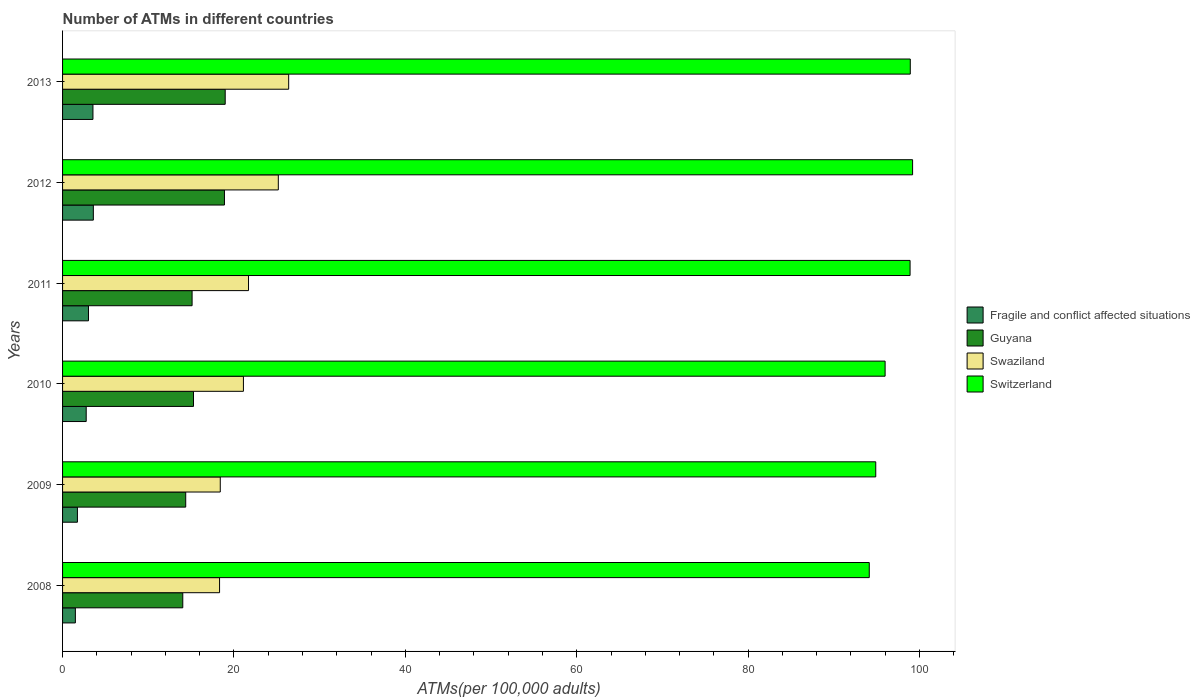How many different coloured bars are there?
Your response must be concise. 4. How many groups of bars are there?
Keep it short and to the point. 6. Are the number of bars per tick equal to the number of legend labels?
Ensure brevity in your answer.  Yes. How many bars are there on the 3rd tick from the top?
Provide a succinct answer. 4. In how many cases, is the number of bars for a given year not equal to the number of legend labels?
Offer a terse response. 0. What is the number of ATMs in Switzerland in 2009?
Offer a very short reply. 94.89. Across all years, what is the maximum number of ATMs in Guyana?
Ensure brevity in your answer.  18.98. Across all years, what is the minimum number of ATMs in Fragile and conflict affected situations?
Keep it short and to the point. 1.49. What is the total number of ATMs in Fragile and conflict affected situations in the graph?
Your answer should be very brief. 16.15. What is the difference between the number of ATMs in Guyana in 2011 and that in 2013?
Give a very brief answer. -3.86. What is the difference between the number of ATMs in Guyana in 2011 and the number of ATMs in Switzerland in 2013?
Provide a succinct answer. -83.81. What is the average number of ATMs in Swaziland per year?
Provide a succinct answer. 21.85. In the year 2008, what is the difference between the number of ATMs in Switzerland and number of ATMs in Fragile and conflict affected situations?
Give a very brief answer. 92.64. What is the ratio of the number of ATMs in Swaziland in 2008 to that in 2011?
Give a very brief answer. 0.84. Is the difference between the number of ATMs in Switzerland in 2008 and 2010 greater than the difference between the number of ATMs in Fragile and conflict affected situations in 2008 and 2010?
Give a very brief answer. No. What is the difference between the highest and the second highest number of ATMs in Guyana?
Give a very brief answer. 0.09. What is the difference between the highest and the lowest number of ATMs in Guyana?
Your answer should be very brief. 4.95. In how many years, is the number of ATMs in Swaziland greater than the average number of ATMs in Swaziland taken over all years?
Provide a succinct answer. 2. Is the sum of the number of ATMs in Swaziland in 2008 and 2012 greater than the maximum number of ATMs in Fragile and conflict affected situations across all years?
Make the answer very short. Yes. Is it the case that in every year, the sum of the number of ATMs in Guyana and number of ATMs in Switzerland is greater than the sum of number of ATMs in Fragile and conflict affected situations and number of ATMs in Swaziland?
Your response must be concise. Yes. What does the 2nd bar from the top in 2010 represents?
Make the answer very short. Swaziland. What does the 1st bar from the bottom in 2009 represents?
Keep it short and to the point. Fragile and conflict affected situations. Is it the case that in every year, the sum of the number of ATMs in Switzerland and number of ATMs in Guyana is greater than the number of ATMs in Swaziland?
Keep it short and to the point. Yes. How many bars are there?
Provide a short and direct response. 24. Are all the bars in the graph horizontal?
Keep it short and to the point. Yes. Are the values on the major ticks of X-axis written in scientific E-notation?
Make the answer very short. No. Does the graph contain any zero values?
Make the answer very short. No. Does the graph contain grids?
Make the answer very short. No. How many legend labels are there?
Your answer should be very brief. 4. How are the legend labels stacked?
Provide a succinct answer. Vertical. What is the title of the graph?
Give a very brief answer. Number of ATMs in different countries. What is the label or title of the X-axis?
Provide a short and direct response. ATMs(per 100,0 adults). What is the label or title of the Y-axis?
Offer a terse response. Years. What is the ATMs(per 100,000 adults) in Fragile and conflict affected situations in 2008?
Provide a succinct answer. 1.49. What is the ATMs(per 100,000 adults) of Guyana in 2008?
Your answer should be compact. 14.03. What is the ATMs(per 100,000 adults) of Swaziland in 2008?
Provide a succinct answer. 18.32. What is the ATMs(per 100,000 adults) of Switzerland in 2008?
Offer a very short reply. 94.14. What is the ATMs(per 100,000 adults) in Fragile and conflict affected situations in 2009?
Keep it short and to the point. 1.73. What is the ATMs(per 100,000 adults) of Guyana in 2009?
Offer a very short reply. 14.37. What is the ATMs(per 100,000 adults) in Swaziland in 2009?
Provide a short and direct response. 18.4. What is the ATMs(per 100,000 adults) in Switzerland in 2009?
Ensure brevity in your answer.  94.89. What is the ATMs(per 100,000 adults) in Fragile and conflict affected situations in 2010?
Provide a succinct answer. 2.76. What is the ATMs(per 100,000 adults) in Guyana in 2010?
Your answer should be very brief. 15.28. What is the ATMs(per 100,000 adults) in Swaziland in 2010?
Provide a short and direct response. 21.1. What is the ATMs(per 100,000 adults) of Switzerland in 2010?
Your answer should be compact. 95.98. What is the ATMs(per 100,000 adults) in Fragile and conflict affected situations in 2011?
Your response must be concise. 3.02. What is the ATMs(per 100,000 adults) in Guyana in 2011?
Your answer should be very brief. 15.12. What is the ATMs(per 100,000 adults) of Swaziland in 2011?
Make the answer very short. 21.7. What is the ATMs(per 100,000 adults) of Switzerland in 2011?
Make the answer very short. 98.9. What is the ATMs(per 100,000 adults) of Fragile and conflict affected situations in 2012?
Offer a very short reply. 3.59. What is the ATMs(per 100,000 adults) of Guyana in 2012?
Make the answer very short. 18.89. What is the ATMs(per 100,000 adults) of Swaziland in 2012?
Make the answer very short. 25.18. What is the ATMs(per 100,000 adults) in Switzerland in 2012?
Keep it short and to the point. 99.19. What is the ATMs(per 100,000 adults) in Fragile and conflict affected situations in 2013?
Make the answer very short. 3.55. What is the ATMs(per 100,000 adults) of Guyana in 2013?
Your response must be concise. 18.98. What is the ATMs(per 100,000 adults) of Swaziland in 2013?
Ensure brevity in your answer.  26.38. What is the ATMs(per 100,000 adults) of Switzerland in 2013?
Provide a succinct answer. 98.92. Across all years, what is the maximum ATMs(per 100,000 adults) in Fragile and conflict affected situations?
Make the answer very short. 3.59. Across all years, what is the maximum ATMs(per 100,000 adults) in Guyana?
Your answer should be compact. 18.98. Across all years, what is the maximum ATMs(per 100,000 adults) of Swaziland?
Give a very brief answer. 26.38. Across all years, what is the maximum ATMs(per 100,000 adults) in Switzerland?
Offer a very short reply. 99.19. Across all years, what is the minimum ATMs(per 100,000 adults) in Fragile and conflict affected situations?
Make the answer very short. 1.49. Across all years, what is the minimum ATMs(per 100,000 adults) in Guyana?
Make the answer very short. 14.03. Across all years, what is the minimum ATMs(per 100,000 adults) of Swaziland?
Provide a succinct answer. 18.32. Across all years, what is the minimum ATMs(per 100,000 adults) in Switzerland?
Your answer should be very brief. 94.14. What is the total ATMs(per 100,000 adults) in Fragile and conflict affected situations in the graph?
Offer a very short reply. 16.15. What is the total ATMs(per 100,000 adults) of Guyana in the graph?
Your response must be concise. 96.66. What is the total ATMs(per 100,000 adults) in Swaziland in the graph?
Your answer should be compact. 131.09. What is the total ATMs(per 100,000 adults) of Switzerland in the graph?
Ensure brevity in your answer.  582.03. What is the difference between the ATMs(per 100,000 adults) of Fragile and conflict affected situations in 2008 and that in 2009?
Ensure brevity in your answer.  -0.24. What is the difference between the ATMs(per 100,000 adults) in Guyana in 2008 and that in 2009?
Offer a very short reply. -0.34. What is the difference between the ATMs(per 100,000 adults) in Swaziland in 2008 and that in 2009?
Offer a very short reply. -0.08. What is the difference between the ATMs(per 100,000 adults) in Switzerland in 2008 and that in 2009?
Provide a short and direct response. -0.76. What is the difference between the ATMs(per 100,000 adults) of Fragile and conflict affected situations in 2008 and that in 2010?
Offer a very short reply. -1.26. What is the difference between the ATMs(per 100,000 adults) in Guyana in 2008 and that in 2010?
Give a very brief answer. -1.25. What is the difference between the ATMs(per 100,000 adults) in Swaziland in 2008 and that in 2010?
Keep it short and to the point. -2.78. What is the difference between the ATMs(per 100,000 adults) of Switzerland in 2008 and that in 2010?
Your answer should be very brief. -1.85. What is the difference between the ATMs(per 100,000 adults) of Fragile and conflict affected situations in 2008 and that in 2011?
Make the answer very short. -1.53. What is the difference between the ATMs(per 100,000 adults) in Guyana in 2008 and that in 2011?
Give a very brief answer. -1.09. What is the difference between the ATMs(per 100,000 adults) in Swaziland in 2008 and that in 2011?
Give a very brief answer. -3.38. What is the difference between the ATMs(per 100,000 adults) in Switzerland in 2008 and that in 2011?
Make the answer very short. -4.76. What is the difference between the ATMs(per 100,000 adults) of Fragile and conflict affected situations in 2008 and that in 2012?
Your answer should be very brief. -2.1. What is the difference between the ATMs(per 100,000 adults) of Guyana in 2008 and that in 2012?
Your answer should be compact. -4.86. What is the difference between the ATMs(per 100,000 adults) of Swaziland in 2008 and that in 2012?
Provide a succinct answer. -6.86. What is the difference between the ATMs(per 100,000 adults) in Switzerland in 2008 and that in 2012?
Make the answer very short. -5.06. What is the difference between the ATMs(per 100,000 adults) in Fragile and conflict affected situations in 2008 and that in 2013?
Offer a very short reply. -2.05. What is the difference between the ATMs(per 100,000 adults) of Guyana in 2008 and that in 2013?
Your answer should be very brief. -4.95. What is the difference between the ATMs(per 100,000 adults) of Swaziland in 2008 and that in 2013?
Offer a terse response. -8.06. What is the difference between the ATMs(per 100,000 adults) in Switzerland in 2008 and that in 2013?
Offer a very short reply. -4.79. What is the difference between the ATMs(per 100,000 adults) in Fragile and conflict affected situations in 2009 and that in 2010?
Your answer should be very brief. -1.03. What is the difference between the ATMs(per 100,000 adults) in Guyana in 2009 and that in 2010?
Keep it short and to the point. -0.91. What is the difference between the ATMs(per 100,000 adults) in Swaziland in 2009 and that in 2010?
Your response must be concise. -2.7. What is the difference between the ATMs(per 100,000 adults) in Switzerland in 2009 and that in 2010?
Make the answer very short. -1.09. What is the difference between the ATMs(per 100,000 adults) in Fragile and conflict affected situations in 2009 and that in 2011?
Provide a short and direct response. -1.29. What is the difference between the ATMs(per 100,000 adults) in Guyana in 2009 and that in 2011?
Offer a terse response. -0.75. What is the difference between the ATMs(per 100,000 adults) of Swaziland in 2009 and that in 2011?
Give a very brief answer. -3.3. What is the difference between the ATMs(per 100,000 adults) in Switzerland in 2009 and that in 2011?
Give a very brief answer. -4. What is the difference between the ATMs(per 100,000 adults) in Fragile and conflict affected situations in 2009 and that in 2012?
Your answer should be very brief. -1.86. What is the difference between the ATMs(per 100,000 adults) in Guyana in 2009 and that in 2012?
Give a very brief answer. -4.52. What is the difference between the ATMs(per 100,000 adults) of Swaziland in 2009 and that in 2012?
Provide a short and direct response. -6.77. What is the difference between the ATMs(per 100,000 adults) in Switzerland in 2009 and that in 2012?
Give a very brief answer. -4.3. What is the difference between the ATMs(per 100,000 adults) of Fragile and conflict affected situations in 2009 and that in 2013?
Provide a succinct answer. -1.81. What is the difference between the ATMs(per 100,000 adults) in Guyana in 2009 and that in 2013?
Your answer should be compact. -4.61. What is the difference between the ATMs(per 100,000 adults) of Swaziland in 2009 and that in 2013?
Make the answer very short. -7.98. What is the difference between the ATMs(per 100,000 adults) in Switzerland in 2009 and that in 2013?
Give a very brief answer. -4.03. What is the difference between the ATMs(per 100,000 adults) of Fragile and conflict affected situations in 2010 and that in 2011?
Offer a terse response. -0.27. What is the difference between the ATMs(per 100,000 adults) of Guyana in 2010 and that in 2011?
Your answer should be very brief. 0.16. What is the difference between the ATMs(per 100,000 adults) in Swaziland in 2010 and that in 2011?
Your answer should be compact. -0.6. What is the difference between the ATMs(per 100,000 adults) of Switzerland in 2010 and that in 2011?
Ensure brevity in your answer.  -2.91. What is the difference between the ATMs(per 100,000 adults) in Fragile and conflict affected situations in 2010 and that in 2012?
Keep it short and to the point. -0.83. What is the difference between the ATMs(per 100,000 adults) of Guyana in 2010 and that in 2012?
Offer a terse response. -3.61. What is the difference between the ATMs(per 100,000 adults) in Swaziland in 2010 and that in 2012?
Make the answer very short. -4.07. What is the difference between the ATMs(per 100,000 adults) in Switzerland in 2010 and that in 2012?
Provide a short and direct response. -3.21. What is the difference between the ATMs(per 100,000 adults) of Fragile and conflict affected situations in 2010 and that in 2013?
Make the answer very short. -0.79. What is the difference between the ATMs(per 100,000 adults) in Guyana in 2010 and that in 2013?
Keep it short and to the point. -3.7. What is the difference between the ATMs(per 100,000 adults) in Swaziland in 2010 and that in 2013?
Offer a very short reply. -5.28. What is the difference between the ATMs(per 100,000 adults) in Switzerland in 2010 and that in 2013?
Keep it short and to the point. -2.94. What is the difference between the ATMs(per 100,000 adults) in Fragile and conflict affected situations in 2011 and that in 2012?
Provide a short and direct response. -0.57. What is the difference between the ATMs(per 100,000 adults) in Guyana in 2011 and that in 2012?
Keep it short and to the point. -3.78. What is the difference between the ATMs(per 100,000 adults) of Swaziland in 2011 and that in 2012?
Give a very brief answer. -3.48. What is the difference between the ATMs(per 100,000 adults) of Switzerland in 2011 and that in 2012?
Offer a terse response. -0.29. What is the difference between the ATMs(per 100,000 adults) in Fragile and conflict affected situations in 2011 and that in 2013?
Offer a terse response. -0.52. What is the difference between the ATMs(per 100,000 adults) in Guyana in 2011 and that in 2013?
Ensure brevity in your answer.  -3.86. What is the difference between the ATMs(per 100,000 adults) in Swaziland in 2011 and that in 2013?
Your answer should be very brief. -4.68. What is the difference between the ATMs(per 100,000 adults) in Switzerland in 2011 and that in 2013?
Make the answer very short. -0.03. What is the difference between the ATMs(per 100,000 adults) of Fragile and conflict affected situations in 2012 and that in 2013?
Provide a succinct answer. 0.05. What is the difference between the ATMs(per 100,000 adults) of Guyana in 2012 and that in 2013?
Offer a very short reply. -0.09. What is the difference between the ATMs(per 100,000 adults) in Swaziland in 2012 and that in 2013?
Ensure brevity in your answer.  -1.21. What is the difference between the ATMs(per 100,000 adults) of Switzerland in 2012 and that in 2013?
Keep it short and to the point. 0.27. What is the difference between the ATMs(per 100,000 adults) of Fragile and conflict affected situations in 2008 and the ATMs(per 100,000 adults) of Guyana in 2009?
Keep it short and to the point. -12.88. What is the difference between the ATMs(per 100,000 adults) of Fragile and conflict affected situations in 2008 and the ATMs(per 100,000 adults) of Swaziland in 2009?
Make the answer very short. -16.91. What is the difference between the ATMs(per 100,000 adults) of Fragile and conflict affected situations in 2008 and the ATMs(per 100,000 adults) of Switzerland in 2009?
Your answer should be very brief. -93.4. What is the difference between the ATMs(per 100,000 adults) of Guyana in 2008 and the ATMs(per 100,000 adults) of Swaziland in 2009?
Offer a very short reply. -4.37. What is the difference between the ATMs(per 100,000 adults) of Guyana in 2008 and the ATMs(per 100,000 adults) of Switzerland in 2009?
Offer a terse response. -80.87. What is the difference between the ATMs(per 100,000 adults) of Swaziland in 2008 and the ATMs(per 100,000 adults) of Switzerland in 2009?
Keep it short and to the point. -76.57. What is the difference between the ATMs(per 100,000 adults) of Fragile and conflict affected situations in 2008 and the ATMs(per 100,000 adults) of Guyana in 2010?
Offer a terse response. -13.79. What is the difference between the ATMs(per 100,000 adults) in Fragile and conflict affected situations in 2008 and the ATMs(per 100,000 adults) in Swaziland in 2010?
Provide a short and direct response. -19.61. What is the difference between the ATMs(per 100,000 adults) of Fragile and conflict affected situations in 2008 and the ATMs(per 100,000 adults) of Switzerland in 2010?
Give a very brief answer. -94.49. What is the difference between the ATMs(per 100,000 adults) in Guyana in 2008 and the ATMs(per 100,000 adults) in Swaziland in 2010?
Offer a very short reply. -7.08. What is the difference between the ATMs(per 100,000 adults) of Guyana in 2008 and the ATMs(per 100,000 adults) of Switzerland in 2010?
Provide a succinct answer. -81.96. What is the difference between the ATMs(per 100,000 adults) of Swaziland in 2008 and the ATMs(per 100,000 adults) of Switzerland in 2010?
Your response must be concise. -77.66. What is the difference between the ATMs(per 100,000 adults) of Fragile and conflict affected situations in 2008 and the ATMs(per 100,000 adults) of Guyana in 2011?
Give a very brief answer. -13.62. What is the difference between the ATMs(per 100,000 adults) in Fragile and conflict affected situations in 2008 and the ATMs(per 100,000 adults) in Swaziland in 2011?
Your answer should be compact. -20.21. What is the difference between the ATMs(per 100,000 adults) of Fragile and conflict affected situations in 2008 and the ATMs(per 100,000 adults) of Switzerland in 2011?
Ensure brevity in your answer.  -97.4. What is the difference between the ATMs(per 100,000 adults) in Guyana in 2008 and the ATMs(per 100,000 adults) in Swaziland in 2011?
Keep it short and to the point. -7.67. What is the difference between the ATMs(per 100,000 adults) in Guyana in 2008 and the ATMs(per 100,000 adults) in Switzerland in 2011?
Your answer should be compact. -84.87. What is the difference between the ATMs(per 100,000 adults) of Swaziland in 2008 and the ATMs(per 100,000 adults) of Switzerland in 2011?
Offer a very short reply. -80.58. What is the difference between the ATMs(per 100,000 adults) of Fragile and conflict affected situations in 2008 and the ATMs(per 100,000 adults) of Guyana in 2012?
Make the answer very short. -17.4. What is the difference between the ATMs(per 100,000 adults) in Fragile and conflict affected situations in 2008 and the ATMs(per 100,000 adults) in Swaziland in 2012?
Offer a very short reply. -23.68. What is the difference between the ATMs(per 100,000 adults) in Fragile and conflict affected situations in 2008 and the ATMs(per 100,000 adults) in Switzerland in 2012?
Your response must be concise. -97.7. What is the difference between the ATMs(per 100,000 adults) of Guyana in 2008 and the ATMs(per 100,000 adults) of Swaziland in 2012?
Keep it short and to the point. -11.15. What is the difference between the ATMs(per 100,000 adults) of Guyana in 2008 and the ATMs(per 100,000 adults) of Switzerland in 2012?
Keep it short and to the point. -85.17. What is the difference between the ATMs(per 100,000 adults) in Swaziland in 2008 and the ATMs(per 100,000 adults) in Switzerland in 2012?
Offer a terse response. -80.87. What is the difference between the ATMs(per 100,000 adults) in Fragile and conflict affected situations in 2008 and the ATMs(per 100,000 adults) in Guyana in 2013?
Provide a short and direct response. -17.48. What is the difference between the ATMs(per 100,000 adults) in Fragile and conflict affected situations in 2008 and the ATMs(per 100,000 adults) in Swaziland in 2013?
Your answer should be compact. -24.89. What is the difference between the ATMs(per 100,000 adults) in Fragile and conflict affected situations in 2008 and the ATMs(per 100,000 adults) in Switzerland in 2013?
Ensure brevity in your answer.  -97.43. What is the difference between the ATMs(per 100,000 adults) of Guyana in 2008 and the ATMs(per 100,000 adults) of Swaziland in 2013?
Make the answer very short. -12.36. What is the difference between the ATMs(per 100,000 adults) of Guyana in 2008 and the ATMs(per 100,000 adults) of Switzerland in 2013?
Offer a terse response. -84.9. What is the difference between the ATMs(per 100,000 adults) of Swaziland in 2008 and the ATMs(per 100,000 adults) of Switzerland in 2013?
Provide a short and direct response. -80.6. What is the difference between the ATMs(per 100,000 adults) in Fragile and conflict affected situations in 2009 and the ATMs(per 100,000 adults) in Guyana in 2010?
Your answer should be compact. -13.55. What is the difference between the ATMs(per 100,000 adults) in Fragile and conflict affected situations in 2009 and the ATMs(per 100,000 adults) in Swaziland in 2010?
Your answer should be compact. -19.37. What is the difference between the ATMs(per 100,000 adults) in Fragile and conflict affected situations in 2009 and the ATMs(per 100,000 adults) in Switzerland in 2010?
Ensure brevity in your answer.  -94.25. What is the difference between the ATMs(per 100,000 adults) in Guyana in 2009 and the ATMs(per 100,000 adults) in Swaziland in 2010?
Offer a very short reply. -6.73. What is the difference between the ATMs(per 100,000 adults) of Guyana in 2009 and the ATMs(per 100,000 adults) of Switzerland in 2010?
Offer a terse response. -81.61. What is the difference between the ATMs(per 100,000 adults) of Swaziland in 2009 and the ATMs(per 100,000 adults) of Switzerland in 2010?
Offer a very short reply. -77.58. What is the difference between the ATMs(per 100,000 adults) in Fragile and conflict affected situations in 2009 and the ATMs(per 100,000 adults) in Guyana in 2011?
Provide a short and direct response. -13.38. What is the difference between the ATMs(per 100,000 adults) of Fragile and conflict affected situations in 2009 and the ATMs(per 100,000 adults) of Swaziland in 2011?
Provide a succinct answer. -19.97. What is the difference between the ATMs(per 100,000 adults) in Fragile and conflict affected situations in 2009 and the ATMs(per 100,000 adults) in Switzerland in 2011?
Make the answer very short. -97.17. What is the difference between the ATMs(per 100,000 adults) of Guyana in 2009 and the ATMs(per 100,000 adults) of Swaziland in 2011?
Ensure brevity in your answer.  -7.33. What is the difference between the ATMs(per 100,000 adults) of Guyana in 2009 and the ATMs(per 100,000 adults) of Switzerland in 2011?
Your answer should be very brief. -84.53. What is the difference between the ATMs(per 100,000 adults) of Swaziland in 2009 and the ATMs(per 100,000 adults) of Switzerland in 2011?
Give a very brief answer. -80.5. What is the difference between the ATMs(per 100,000 adults) in Fragile and conflict affected situations in 2009 and the ATMs(per 100,000 adults) in Guyana in 2012?
Your answer should be very brief. -17.16. What is the difference between the ATMs(per 100,000 adults) of Fragile and conflict affected situations in 2009 and the ATMs(per 100,000 adults) of Swaziland in 2012?
Provide a short and direct response. -23.44. What is the difference between the ATMs(per 100,000 adults) in Fragile and conflict affected situations in 2009 and the ATMs(per 100,000 adults) in Switzerland in 2012?
Your answer should be very brief. -97.46. What is the difference between the ATMs(per 100,000 adults) in Guyana in 2009 and the ATMs(per 100,000 adults) in Swaziland in 2012?
Provide a short and direct response. -10.8. What is the difference between the ATMs(per 100,000 adults) of Guyana in 2009 and the ATMs(per 100,000 adults) of Switzerland in 2012?
Provide a short and direct response. -84.82. What is the difference between the ATMs(per 100,000 adults) in Swaziland in 2009 and the ATMs(per 100,000 adults) in Switzerland in 2012?
Your answer should be compact. -80.79. What is the difference between the ATMs(per 100,000 adults) in Fragile and conflict affected situations in 2009 and the ATMs(per 100,000 adults) in Guyana in 2013?
Give a very brief answer. -17.25. What is the difference between the ATMs(per 100,000 adults) in Fragile and conflict affected situations in 2009 and the ATMs(per 100,000 adults) in Swaziland in 2013?
Ensure brevity in your answer.  -24.65. What is the difference between the ATMs(per 100,000 adults) of Fragile and conflict affected situations in 2009 and the ATMs(per 100,000 adults) of Switzerland in 2013?
Your response must be concise. -97.19. What is the difference between the ATMs(per 100,000 adults) in Guyana in 2009 and the ATMs(per 100,000 adults) in Swaziland in 2013?
Your answer should be compact. -12.01. What is the difference between the ATMs(per 100,000 adults) in Guyana in 2009 and the ATMs(per 100,000 adults) in Switzerland in 2013?
Ensure brevity in your answer.  -84.55. What is the difference between the ATMs(per 100,000 adults) of Swaziland in 2009 and the ATMs(per 100,000 adults) of Switzerland in 2013?
Give a very brief answer. -80.52. What is the difference between the ATMs(per 100,000 adults) of Fragile and conflict affected situations in 2010 and the ATMs(per 100,000 adults) of Guyana in 2011?
Your answer should be compact. -12.36. What is the difference between the ATMs(per 100,000 adults) in Fragile and conflict affected situations in 2010 and the ATMs(per 100,000 adults) in Swaziland in 2011?
Offer a terse response. -18.94. What is the difference between the ATMs(per 100,000 adults) in Fragile and conflict affected situations in 2010 and the ATMs(per 100,000 adults) in Switzerland in 2011?
Your answer should be very brief. -96.14. What is the difference between the ATMs(per 100,000 adults) in Guyana in 2010 and the ATMs(per 100,000 adults) in Swaziland in 2011?
Provide a succinct answer. -6.42. What is the difference between the ATMs(per 100,000 adults) of Guyana in 2010 and the ATMs(per 100,000 adults) of Switzerland in 2011?
Offer a very short reply. -83.62. What is the difference between the ATMs(per 100,000 adults) in Swaziland in 2010 and the ATMs(per 100,000 adults) in Switzerland in 2011?
Give a very brief answer. -77.79. What is the difference between the ATMs(per 100,000 adults) of Fragile and conflict affected situations in 2010 and the ATMs(per 100,000 adults) of Guyana in 2012?
Provide a short and direct response. -16.13. What is the difference between the ATMs(per 100,000 adults) of Fragile and conflict affected situations in 2010 and the ATMs(per 100,000 adults) of Swaziland in 2012?
Provide a short and direct response. -22.42. What is the difference between the ATMs(per 100,000 adults) of Fragile and conflict affected situations in 2010 and the ATMs(per 100,000 adults) of Switzerland in 2012?
Your answer should be very brief. -96.43. What is the difference between the ATMs(per 100,000 adults) in Guyana in 2010 and the ATMs(per 100,000 adults) in Swaziland in 2012?
Provide a succinct answer. -9.9. What is the difference between the ATMs(per 100,000 adults) in Guyana in 2010 and the ATMs(per 100,000 adults) in Switzerland in 2012?
Your response must be concise. -83.91. What is the difference between the ATMs(per 100,000 adults) of Swaziland in 2010 and the ATMs(per 100,000 adults) of Switzerland in 2012?
Ensure brevity in your answer.  -78.09. What is the difference between the ATMs(per 100,000 adults) of Fragile and conflict affected situations in 2010 and the ATMs(per 100,000 adults) of Guyana in 2013?
Ensure brevity in your answer.  -16.22. What is the difference between the ATMs(per 100,000 adults) in Fragile and conflict affected situations in 2010 and the ATMs(per 100,000 adults) in Swaziland in 2013?
Offer a terse response. -23.63. What is the difference between the ATMs(per 100,000 adults) of Fragile and conflict affected situations in 2010 and the ATMs(per 100,000 adults) of Switzerland in 2013?
Keep it short and to the point. -96.16. What is the difference between the ATMs(per 100,000 adults) of Guyana in 2010 and the ATMs(per 100,000 adults) of Swaziland in 2013?
Give a very brief answer. -11.11. What is the difference between the ATMs(per 100,000 adults) in Guyana in 2010 and the ATMs(per 100,000 adults) in Switzerland in 2013?
Provide a succinct answer. -83.64. What is the difference between the ATMs(per 100,000 adults) in Swaziland in 2010 and the ATMs(per 100,000 adults) in Switzerland in 2013?
Your response must be concise. -77.82. What is the difference between the ATMs(per 100,000 adults) of Fragile and conflict affected situations in 2011 and the ATMs(per 100,000 adults) of Guyana in 2012?
Offer a terse response. -15.87. What is the difference between the ATMs(per 100,000 adults) of Fragile and conflict affected situations in 2011 and the ATMs(per 100,000 adults) of Swaziland in 2012?
Make the answer very short. -22.15. What is the difference between the ATMs(per 100,000 adults) of Fragile and conflict affected situations in 2011 and the ATMs(per 100,000 adults) of Switzerland in 2012?
Give a very brief answer. -96.17. What is the difference between the ATMs(per 100,000 adults) of Guyana in 2011 and the ATMs(per 100,000 adults) of Swaziland in 2012?
Offer a terse response. -10.06. What is the difference between the ATMs(per 100,000 adults) in Guyana in 2011 and the ATMs(per 100,000 adults) in Switzerland in 2012?
Ensure brevity in your answer.  -84.08. What is the difference between the ATMs(per 100,000 adults) of Swaziland in 2011 and the ATMs(per 100,000 adults) of Switzerland in 2012?
Offer a very short reply. -77.49. What is the difference between the ATMs(per 100,000 adults) of Fragile and conflict affected situations in 2011 and the ATMs(per 100,000 adults) of Guyana in 2013?
Offer a very short reply. -15.95. What is the difference between the ATMs(per 100,000 adults) in Fragile and conflict affected situations in 2011 and the ATMs(per 100,000 adults) in Swaziland in 2013?
Your answer should be compact. -23.36. What is the difference between the ATMs(per 100,000 adults) in Fragile and conflict affected situations in 2011 and the ATMs(per 100,000 adults) in Switzerland in 2013?
Provide a short and direct response. -95.9. What is the difference between the ATMs(per 100,000 adults) in Guyana in 2011 and the ATMs(per 100,000 adults) in Swaziland in 2013?
Keep it short and to the point. -11.27. What is the difference between the ATMs(per 100,000 adults) in Guyana in 2011 and the ATMs(per 100,000 adults) in Switzerland in 2013?
Make the answer very short. -83.81. What is the difference between the ATMs(per 100,000 adults) in Swaziland in 2011 and the ATMs(per 100,000 adults) in Switzerland in 2013?
Offer a terse response. -77.22. What is the difference between the ATMs(per 100,000 adults) in Fragile and conflict affected situations in 2012 and the ATMs(per 100,000 adults) in Guyana in 2013?
Keep it short and to the point. -15.39. What is the difference between the ATMs(per 100,000 adults) in Fragile and conflict affected situations in 2012 and the ATMs(per 100,000 adults) in Swaziland in 2013?
Offer a terse response. -22.79. What is the difference between the ATMs(per 100,000 adults) of Fragile and conflict affected situations in 2012 and the ATMs(per 100,000 adults) of Switzerland in 2013?
Your answer should be compact. -95.33. What is the difference between the ATMs(per 100,000 adults) in Guyana in 2012 and the ATMs(per 100,000 adults) in Swaziland in 2013?
Your response must be concise. -7.49. What is the difference between the ATMs(per 100,000 adults) in Guyana in 2012 and the ATMs(per 100,000 adults) in Switzerland in 2013?
Offer a very short reply. -80.03. What is the difference between the ATMs(per 100,000 adults) of Swaziland in 2012 and the ATMs(per 100,000 adults) of Switzerland in 2013?
Your answer should be compact. -73.75. What is the average ATMs(per 100,000 adults) of Fragile and conflict affected situations per year?
Offer a terse response. 2.69. What is the average ATMs(per 100,000 adults) in Guyana per year?
Keep it short and to the point. 16.11. What is the average ATMs(per 100,000 adults) of Swaziland per year?
Make the answer very short. 21.85. What is the average ATMs(per 100,000 adults) of Switzerland per year?
Give a very brief answer. 97. In the year 2008, what is the difference between the ATMs(per 100,000 adults) of Fragile and conflict affected situations and ATMs(per 100,000 adults) of Guyana?
Your answer should be compact. -12.53. In the year 2008, what is the difference between the ATMs(per 100,000 adults) in Fragile and conflict affected situations and ATMs(per 100,000 adults) in Swaziland?
Ensure brevity in your answer.  -16.83. In the year 2008, what is the difference between the ATMs(per 100,000 adults) in Fragile and conflict affected situations and ATMs(per 100,000 adults) in Switzerland?
Your answer should be compact. -92.64. In the year 2008, what is the difference between the ATMs(per 100,000 adults) of Guyana and ATMs(per 100,000 adults) of Swaziland?
Make the answer very short. -4.29. In the year 2008, what is the difference between the ATMs(per 100,000 adults) in Guyana and ATMs(per 100,000 adults) in Switzerland?
Offer a very short reply. -80.11. In the year 2008, what is the difference between the ATMs(per 100,000 adults) in Swaziland and ATMs(per 100,000 adults) in Switzerland?
Offer a terse response. -75.82. In the year 2009, what is the difference between the ATMs(per 100,000 adults) in Fragile and conflict affected situations and ATMs(per 100,000 adults) in Guyana?
Your answer should be compact. -12.64. In the year 2009, what is the difference between the ATMs(per 100,000 adults) of Fragile and conflict affected situations and ATMs(per 100,000 adults) of Swaziland?
Offer a very short reply. -16.67. In the year 2009, what is the difference between the ATMs(per 100,000 adults) in Fragile and conflict affected situations and ATMs(per 100,000 adults) in Switzerland?
Provide a short and direct response. -93.16. In the year 2009, what is the difference between the ATMs(per 100,000 adults) in Guyana and ATMs(per 100,000 adults) in Swaziland?
Ensure brevity in your answer.  -4.03. In the year 2009, what is the difference between the ATMs(per 100,000 adults) of Guyana and ATMs(per 100,000 adults) of Switzerland?
Ensure brevity in your answer.  -80.52. In the year 2009, what is the difference between the ATMs(per 100,000 adults) in Swaziland and ATMs(per 100,000 adults) in Switzerland?
Offer a terse response. -76.49. In the year 2010, what is the difference between the ATMs(per 100,000 adults) of Fragile and conflict affected situations and ATMs(per 100,000 adults) of Guyana?
Offer a very short reply. -12.52. In the year 2010, what is the difference between the ATMs(per 100,000 adults) of Fragile and conflict affected situations and ATMs(per 100,000 adults) of Swaziland?
Provide a succinct answer. -18.35. In the year 2010, what is the difference between the ATMs(per 100,000 adults) in Fragile and conflict affected situations and ATMs(per 100,000 adults) in Switzerland?
Offer a terse response. -93.23. In the year 2010, what is the difference between the ATMs(per 100,000 adults) in Guyana and ATMs(per 100,000 adults) in Swaziland?
Provide a short and direct response. -5.83. In the year 2010, what is the difference between the ATMs(per 100,000 adults) of Guyana and ATMs(per 100,000 adults) of Switzerland?
Provide a short and direct response. -80.71. In the year 2010, what is the difference between the ATMs(per 100,000 adults) of Swaziland and ATMs(per 100,000 adults) of Switzerland?
Keep it short and to the point. -74.88. In the year 2011, what is the difference between the ATMs(per 100,000 adults) of Fragile and conflict affected situations and ATMs(per 100,000 adults) of Guyana?
Give a very brief answer. -12.09. In the year 2011, what is the difference between the ATMs(per 100,000 adults) in Fragile and conflict affected situations and ATMs(per 100,000 adults) in Swaziland?
Your response must be concise. -18.67. In the year 2011, what is the difference between the ATMs(per 100,000 adults) of Fragile and conflict affected situations and ATMs(per 100,000 adults) of Switzerland?
Your response must be concise. -95.87. In the year 2011, what is the difference between the ATMs(per 100,000 adults) in Guyana and ATMs(per 100,000 adults) in Swaziland?
Your answer should be compact. -6.58. In the year 2011, what is the difference between the ATMs(per 100,000 adults) of Guyana and ATMs(per 100,000 adults) of Switzerland?
Your response must be concise. -83.78. In the year 2011, what is the difference between the ATMs(per 100,000 adults) of Swaziland and ATMs(per 100,000 adults) of Switzerland?
Your response must be concise. -77.2. In the year 2012, what is the difference between the ATMs(per 100,000 adults) in Fragile and conflict affected situations and ATMs(per 100,000 adults) in Guyana?
Provide a succinct answer. -15.3. In the year 2012, what is the difference between the ATMs(per 100,000 adults) in Fragile and conflict affected situations and ATMs(per 100,000 adults) in Swaziland?
Your answer should be very brief. -21.58. In the year 2012, what is the difference between the ATMs(per 100,000 adults) of Fragile and conflict affected situations and ATMs(per 100,000 adults) of Switzerland?
Your response must be concise. -95.6. In the year 2012, what is the difference between the ATMs(per 100,000 adults) in Guyana and ATMs(per 100,000 adults) in Swaziland?
Provide a succinct answer. -6.28. In the year 2012, what is the difference between the ATMs(per 100,000 adults) in Guyana and ATMs(per 100,000 adults) in Switzerland?
Your answer should be compact. -80.3. In the year 2012, what is the difference between the ATMs(per 100,000 adults) of Swaziland and ATMs(per 100,000 adults) of Switzerland?
Your response must be concise. -74.02. In the year 2013, what is the difference between the ATMs(per 100,000 adults) of Fragile and conflict affected situations and ATMs(per 100,000 adults) of Guyana?
Offer a terse response. -15.43. In the year 2013, what is the difference between the ATMs(per 100,000 adults) of Fragile and conflict affected situations and ATMs(per 100,000 adults) of Swaziland?
Make the answer very short. -22.84. In the year 2013, what is the difference between the ATMs(per 100,000 adults) in Fragile and conflict affected situations and ATMs(per 100,000 adults) in Switzerland?
Keep it short and to the point. -95.38. In the year 2013, what is the difference between the ATMs(per 100,000 adults) in Guyana and ATMs(per 100,000 adults) in Swaziland?
Your answer should be very brief. -7.41. In the year 2013, what is the difference between the ATMs(per 100,000 adults) of Guyana and ATMs(per 100,000 adults) of Switzerland?
Provide a short and direct response. -79.94. In the year 2013, what is the difference between the ATMs(per 100,000 adults) in Swaziland and ATMs(per 100,000 adults) in Switzerland?
Provide a short and direct response. -72.54. What is the ratio of the ATMs(per 100,000 adults) in Fragile and conflict affected situations in 2008 to that in 2009?
Provide a succinct answer. 0.86. What is the ratio of the ATMs(per 100,000 adults) in Guyana in 2008 to that in 2009?
Make the answer very short. 0.98. What is the ratio of the ATMs(per 100,000 adults) of Swaziland in 2008 to that in 2009?
Provide a short and direct response. 1. What is the ratio of the ATMs(per 100,000 adults) in Switzerland in 2008 to that in 2009?
Your answer should be very brief. 0.99. What is the ratio of the ATMs(per 100,000 adults) of Fragile and conflict affected situations in 2008 to that in 2010?
Provide a short and direct response. 0.54. What is the ratio of the ATMs(per 100,000 adults) of Guyana in 2008 to that in 2010?
Give a very brief answer. 0.92. What is the ratio of the ATMs(per 100,000 adults) of Swaziland in 2008 to that in 2010?
Ensure brevity in your answer.  0.87. What is the ratio of the ATMs(per 100,000 adults) of Switzerland in 2008 to that in 2010?
Your answer should be compact. 0.98. What is the ratio of the ATMs(per 100,000 adults) in Fragile and conflict affected situations in 2008 to that in 2011?
Give a very brief answer. 0.49. What is the ratio of the ATMs(per 100,000 adults) of Guyana in 2008 to that in 2011?
Your response must be concise. 0.93. What is the ratio of the ATMs(per 100,000 adults) of Swaziland in 2008 to that in 2011?
Your answer should be very brief. 0.84. What is the ratio of the ATMs(per 100,000 adults) in Switzerland in 2008 to that in 2011?
Keep it short and to the point. 0.95. What is the ratio of the ATMs(per 100,000 adults) in Fragile and conflict affected situations in 2008 to that in 2012?
Make the answer very short. 0.42. What is the ratio of the ATMs(per 100,000 adults) in Guyana in 2008 to that in 2012?
Ensure brevity in your answer.  0.74. What is the ratio of the ATMs(per 100,000 adults) in Swaziland in 2008 to that in 2012?
Ensure brevity in your answer.  0.73. What is the ratio of the ATMs(per 100,000 adults) in Switzerland in 2008 to that in 2012?
Provide a succinct answer. 0.95. What is the ratio of the ATMs(per 100,000 adults) in Fragile and conflict affected situations in 2008 to that in 2013?
Ensure brevity in your answer.  0.42. What is the ratio of the ATMs(per 100,000 adults) of Guyana in 2008 to that in 2013?
Your response must be concise. 0.74. What is the ratio of the ATMs(per 100,000 adults) in Swaziland in 2008 to that in 2013?
Your response must be concise. 0.69. What is the ratio of the ATMs(per 100,000 adults) of Switzerland in 2008 to that in 2013?
Offer a very short reply. 0.95. What is the ratio of the ATMs(per 100,000 adults) in Fragile and conflict affected situations in 2009 to that in 2010?
Your answer should be compact. 0.63. What is the ratio of the ATMs(per 100,000 adults) of Guyana in 2009 to that in 2010?
Your response must be concise. 0.94. What is the ratio of the ATMs(per 100,000 adults) in Swaziland in 2009 to that in 2010?
Provide a succinct answer. 0.87. What is the ratio of the ATMs(per 100,000 adults) of Switzerland in 2009 to that in 2010?
Your answer should be compact. 0.99. What is the ratio of the ATMs(per 100,000 adults) in Fragile and conflict affected situations in 2009 to that in 2011?
Offer a very short reply. 0.57. What is the ratio of the ATMs(per 100,000 adults) in Guyana in 2009 to that in 2011?
Provide a succinct answer. 0.95. What is the ratio of the ATMs(per 100,000 adults) of Swaziland in 2009 to that in 2011?
Your response must be concise. 0.85. What is the ratio of the ATMs(per 100,000 adults) of Switzerland in 2009 to that in 2011?
Give a very brief answer. 0.96. What is the ratio of the ATMs(per 100,000 adults) of Fragile and conflict affected situations in 2009 to that in 2012?
Provide a succinct answer. 0.48. What is the ratio of the ATMs(per 100,000 adults) in Guyana in 2009 to that in 2012?
Provide a short and direct response. 0.76. What is the ratio of the ATMs(per 100,000 adults) of Swaziland in 2009 to that in 2012?
Offer a very short reply. 0.73. What is the ratio of the ATMs(per 100,000 adults) in Switzerland in 2009 to that in 2012?
Offer a very short reply. 0.96. What is the ratio of the ATMs(per 100,000 adults) of Fragile and conflict affected situations in 2009 to that in 2013?
Ensure brevity in your answer.  0.49. What is the ratio of the ATMs(per 100,000 adults) in Guyana in 2009 to that in 2013?
Your answer should be compact. 0.76. What is the ratio of the ATMs(per 100,000 adults) in Swaziland in 2009 to that in 2013?
Offer a terse response. 0.7. What is the ratio of the ATMs(per 100,000 adults) of Switzerland in 2009 to that in 2013?
Make the answer very short. 0.96. What is the ratio of the ATMs(per 100,000 adults) in Fragile and conflict affected situations in 2010 to that in 2011?
Make the answer very short. 0.91. What is the ratio of the ATMs(per 100,000 adults) of Guyana in 2010 to that in 2011?
Provide a short and direct response. 1.01. What is the ratio of the ATMs(per 100,000 adults) in Swaziland in 2010 to that in 2011?
Ensure brevity in your answer.  0.97. What is the ratio of the ATMs(per 100,000 adults) of Switzerland in 2010 to that in 2011?
Your response must be concise. 0.97. What is the ratio of the ATMs(per 100,000 adults) in Fragile and conflict affected situations in 2010 to that in 2012?
Offer a terse response. 0.77. What is the ratio of the ATMs(per 100,000 adults) of Guyana in 2010 to that in 2012?
Offer a terse response. 0.81. What is the ratio of the ATMs(per 100,000 adults) of Swaziland in 2010 to that in 2012?
Your answer should be compact. 0.84. What is the ratio of the ATMs(per 100,000 adults) of Fragile and conflict affected situations in 2010 to that in 2013?
Your answer should be compact. 0.78. What is the ratio of the ATMs(per 100,000 adults) of Guyana in 2010 to that in 2013?
Make the answer very short. 0.81. What is the ratio of the ATMs(per 100,000 adults) of Swaziland in 2010 to that in 2013?
Provide a short and direct response. 0.8. What is the ratio of the ATMs(per 100,000 adults) in Switzerland in 2010 to that in 2013?
Make the answer very short. 0.97. What is the ratio of the ATMs(per 100,000 adults) of Fragile and conflict affected situations in 2011 to that in 2012?
Offer a very short reply. 0.84. What is the ratio of the ATMs(per 100,000 adults) of Guyana in 2011 to that in 2012?
Your answer should be compact. 0.8. What is the ratio of the ATMs(per 100,000 adults) of Swaziland in 2011 to that in 2012?
Keep it short and to the point. 0.86. What is the ratio of the ATMs(per 100,000 adults) of Switzerland in 2011 to that in 2012?
Provide a short and direct response. 1. What is the ratio of the ATMs(per 100,000 adults) in Fragile and conflict affected situations in 2011 to that in 2013?
Offer a very short reply. 0.85. What is the ratio of the ATMs(per 100,000 adults) in Guyana in 2011 to that in 2013?
Keep it short and to the point. 0.8. What is the ratio of the ATMs(per 100,000 adults) in Swaziland in 2011 to that in 2013?
Your answer should be compact. 0.82. What is the ratio of the ATMs(per 100,000 adults) in Fragile and conflict affected situations in 2012 to that in 2013?
Keep it short and to the point. 1.01. What is the ratio of the ATMs(per 100,000 adults) of Swaziland in 2012 to that in 2013?
Make the answer very short. 0.95. What is the ratio of the ATMs(per 100,000 adults) in Switzerland in 2012 to that in 2013?
Provide a succinct answer. 1. What is the difference between the highest and the second highest ATMs(per 100,000 adults) of Fragile and conflict affected situations?
Ensure brevity in your answer.  0.05. What is the difference between the highest and the second highest ATMs(per 100,000 adults) in Guyana?
Your answer should be very brief. 0.09. What is the difference between the highest and the second highest ATMs(per 100,000 adults) in Swaziland?
Your answer should be compact. 1.21. What is the difference between the highest and the second highest ATMs(per 100,000 adults) in Switzerland?
Your response must be concise. 0.27. What is the difference between the highest and the lowest ATMs(per 100,000 adults) in Fragile and conflict affected situations?
Offer a terse response. 2.1. What is the difference between the highest and the lowest ATMs(per 100,000 adults) of Guyana?
Give a very brief answer. 4.95. What is the difference between the highest and the lowest ATMs(per 100,000 adults) in Swaziland?
Your response must be concise. 8.06. What is the difference between the highest and the lowest ATMs(per 100,000 adults) in Switzerland?
Your answer should be compact. 5.06. 